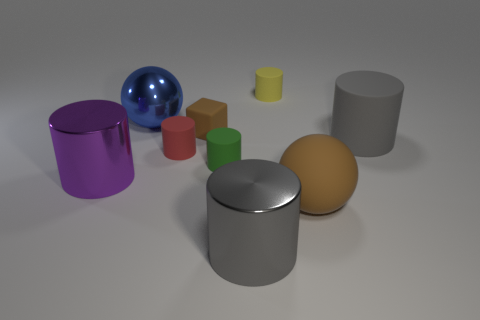Are there any blue objects that have the same shape as the big brown object?
Give a very brief answer. Yes. Are there fewer blocks that are behind the red object than purple metallic blocks?
Give a very brief answer. No. Is the gray shiny thing the same shape as the yellow thing?
Your answer should be very brief. Yes. There is a metallic thing that is in front of the purple cylinder; what is its size?
Provide a succinct answer. Large. The gray thing that is made of the same material as the tiny yellow cylinder is what size?
Your response must be concise. Large. Is the number of red rubber things less than the number of small brown balls?
Keep it short and to the point. No. There is a brown block that is the same size as the yellow matte object; what is it made of?
Provide a short and direct response. Rubber. Is the number of yellow matte balls greater than the number of purple objects?
Ensure brevity in your answer.  No. How many other things are the same color as the matte ball?
Provide a short and direct response. 1. What number of cylinders are both behind the big gray shiny object and in front of the yellow thing?
Offer a terse response. 4. 